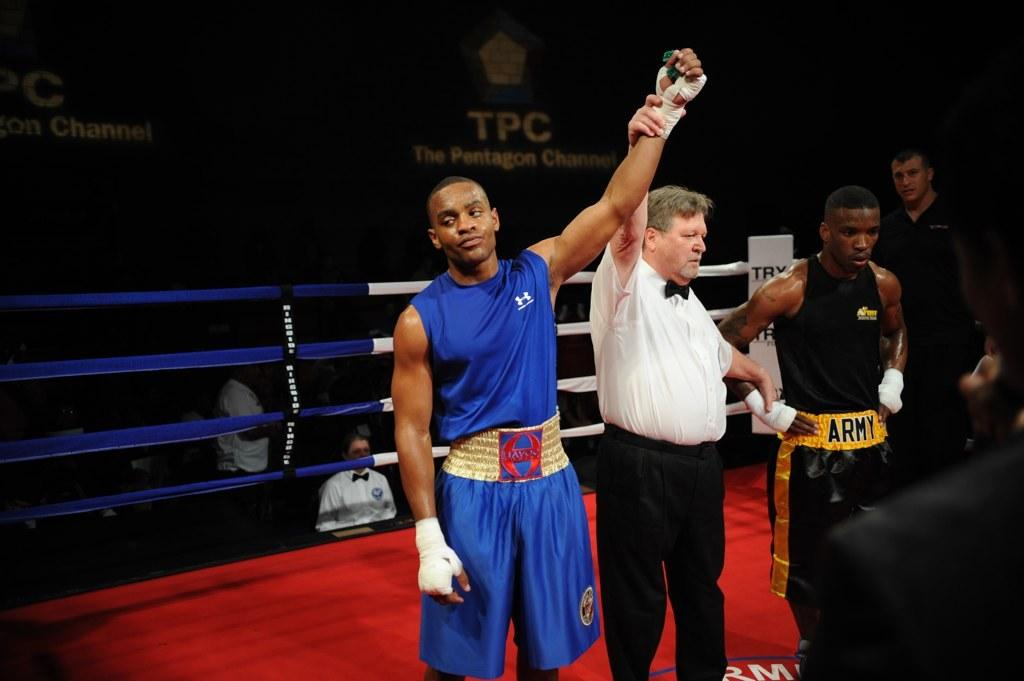<image>
Present a compact description of the photo's key features. Person holding the arm of a man wearing a blue shirt that says Under Armour. 